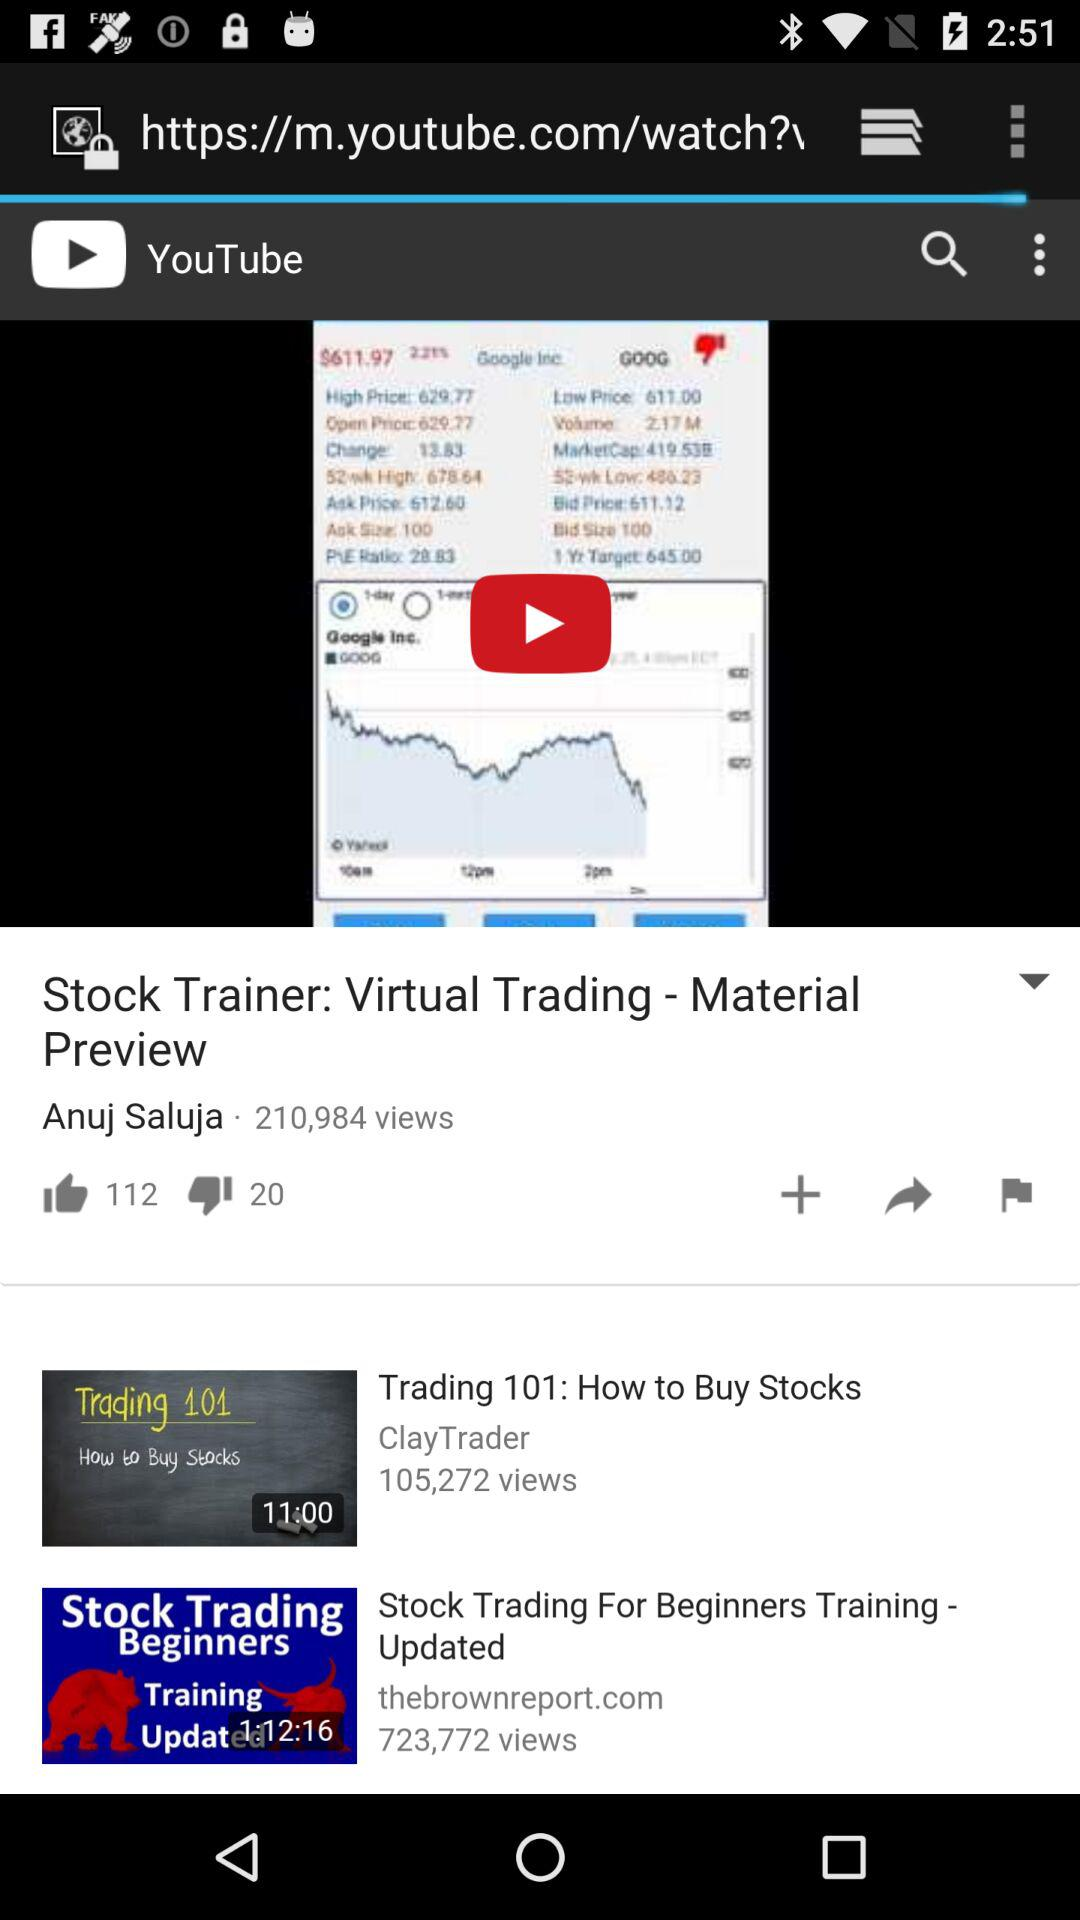How many people have liked the video?
Answer the question using a single word or phrase. 112 people have liked the video 